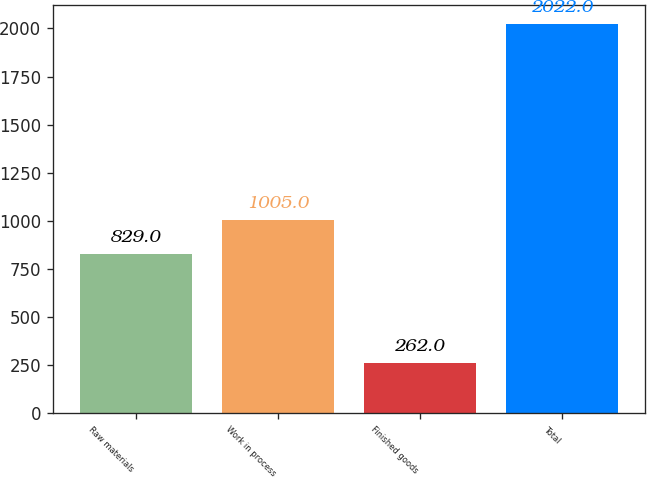Convert chart. <chart><loc_0><loc_0><loc_500><loc_500><bar_chart><fcel>Raw materials<fcel>Work in process<fcel>Finished goods<fcel>Total<nl><fcel>829<fcel>1005<fcel>262<fcel>2022<nl></chart> 